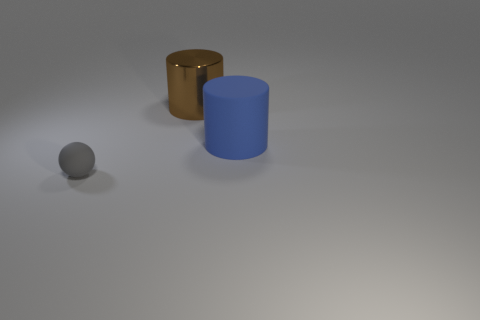Are there any objects that are left of the matte object that is behind the thing left of the brown metal cylinder?
Your answer should be compact. Yes. What number of balls are large purple shiny objects or large rubber objects?
Make the answer very short. 0. The matte object that is to the left of the matte object on the right side of the gray rubber ball is what shape?
Your answer should be very brief. Sphere. What is the size of the cylinder to the left of the rubber thing right of the matte thing that is left of the shiny thing?
Provide a succinct answer. Large. Does the brown metallic cylinder have the same size as the blue rubber thing?
Make the answer very short. Yes. What number of things are either tiny red metallic objects or large metal things?
Your answer should be very brief. 1. What is the size of the thing that is in front of the rubber thing that is to the right of the gray rubber thing?
Provide a succinct answer. Small. The rubber cylinder is what size?
Your answer should be very brief. Large. What is the shape of the thing that is in front of the large brown shiny thing and to the left of the big blue cylinder?
Keep it short and to the point. Sphere. The other large object that is the same shape as the large brown thing is what color?
Keep it short and to the point. Blue. 